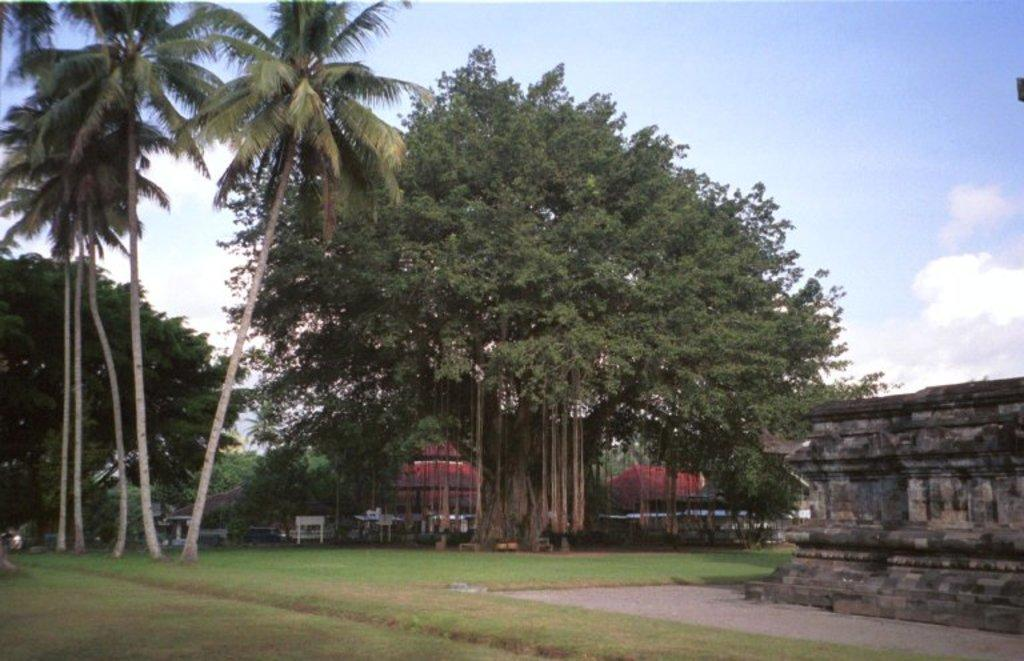What type of vegetation is present in the image? There is grass in the image. What type of structure can be seen in the image? There is a wall in the image. What type of furniture is present in the image? There are tables in the image. image. What type of buildings are visible in the image? There are houses in the image. What type of natural elements are present in the image? There are trees in the image. What is visible in the background of the image? The sky is visible in the background of the image. What can be seen in the sky in the image? There are clouds in the sky. What type of drink is being served at the tax conference in the image? There is no drink or tax conference present in the image. What economic theory is being discussed by the people in the image? There are no people or economic theory being discussed in the image. 